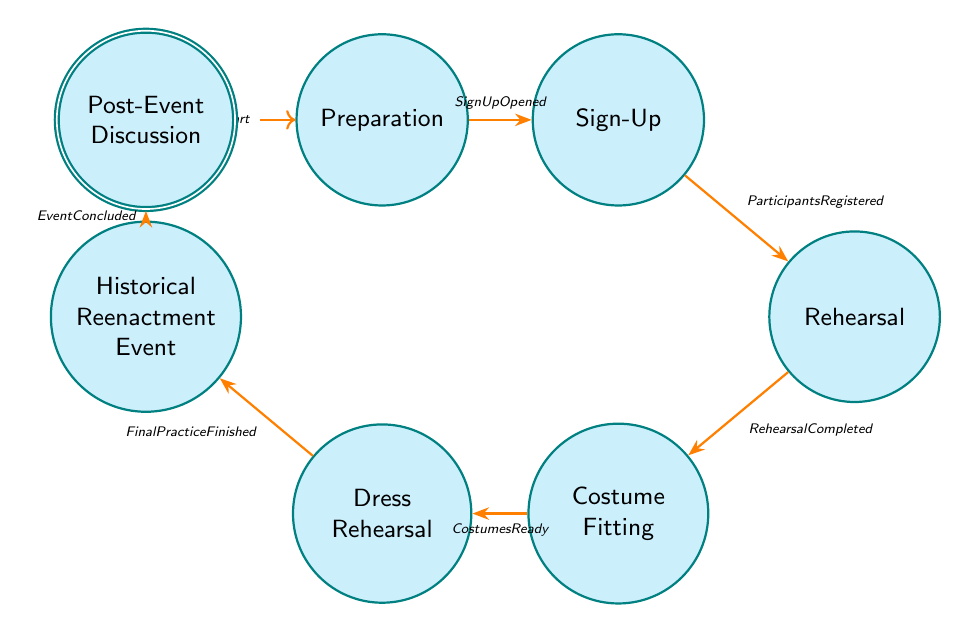What is the first state in the diagram? The first state in the diagram, indicated as the initial state, is labeled "Preparation."
Answer: Preparation How many states are there in total? The diagram contains six distinct states that represent different phases leading to the historical reenactment event.
Answer: 6 What event leads from "Costume Fitting" to "Dress Rehearsal"? The transition from "Costume Fitting" to "Dress Rehearsal" is triggered by the event labeled "CostumesReady."
Answer: CostumesReady What is the last state in the diagram? The last state, which indicates the end of the process, is labeled "Post-Event Discussion."
Answer: Post-Event Discussion Which state follows "Rehearsal"? Based on the transitions in the diagram, the state that follows "Rehearsal" is "Costume Fitting."
Answer: Costume Fitting What event signifies the conclusion of the reenactment event? The event that indicates the conclusion of the historical reenactment event is labeled "EventConcluded."
Answer: EventConcluded Which state does the "FinalPracticeFinished" event lead to? The "FinalPracticeFinished" event leads to the state labeled "Historical Reenactment Event," which is just before the post-event discussion.
Answer: Historical Reenactment Event What are the two states directly connected by the "ParticipantsRegistered" event? The "ParticipantsRegistered" event connects the "Sign-Up" state directly to the "Rehearsal" state in the diagram.
Answer: Sign-Up, Rehearsal How many transitions are there in the diagram? There are a total of six transitions that connect the various states within the diagram.
Answer: 6 